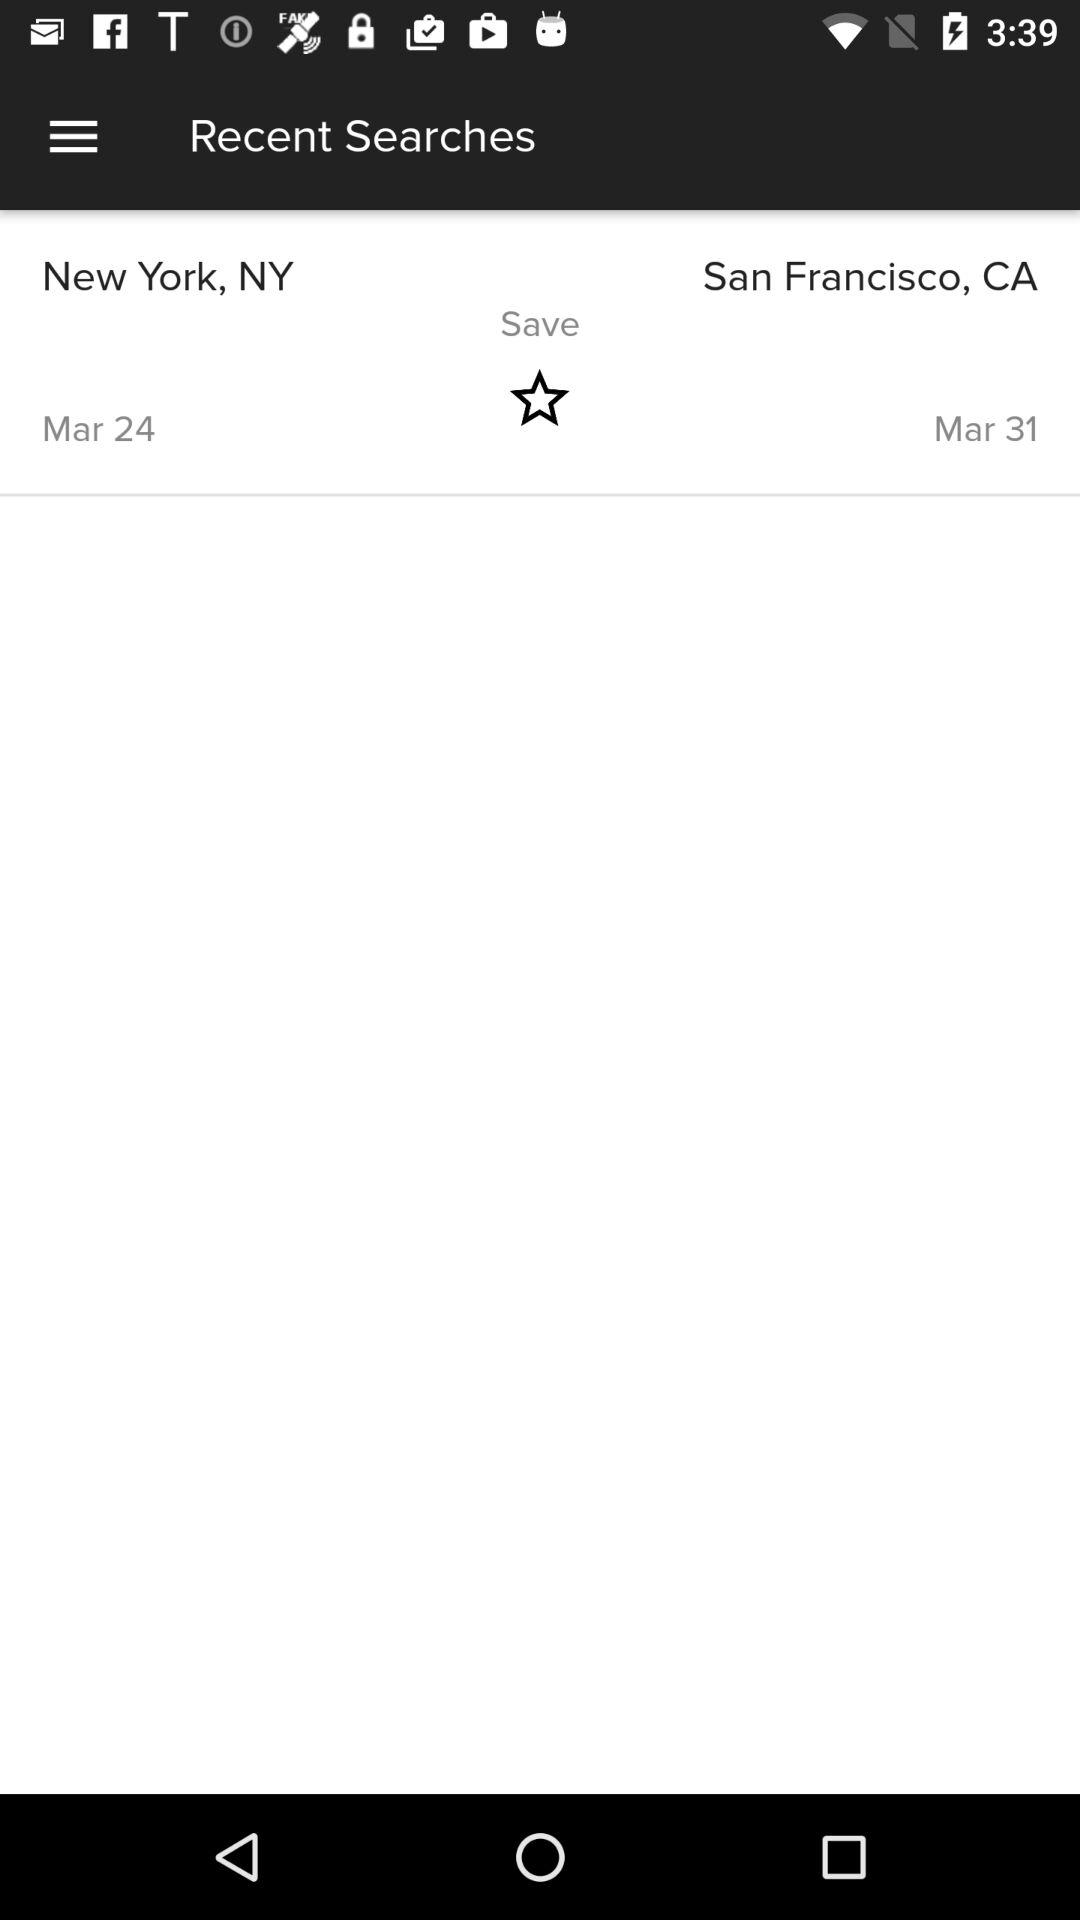What is the end date? The end date is March 31. 